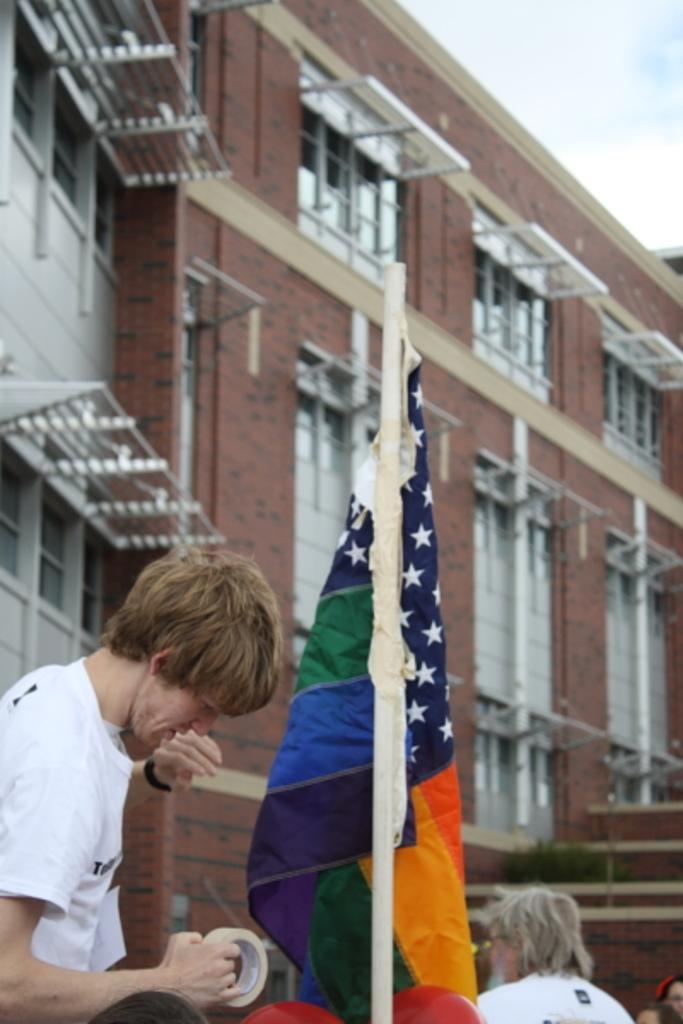Who or what can be seen in the image? There are people in the image. What object is present in the image that represents a country or organization? There is a flag in the image. What type of structure can be seen in the background of the image? There is a building with windows in the background. What is visible in the sky at the top of the image? Clouds are visible in the sky at the top of the image. What type of lace can be seen decorating the flag in the image? There is no lace present on the flag in the image. What type of amusement can be seen in the background of the image? There is no amusement park or any amusement-related objects visible in the background of the image. 